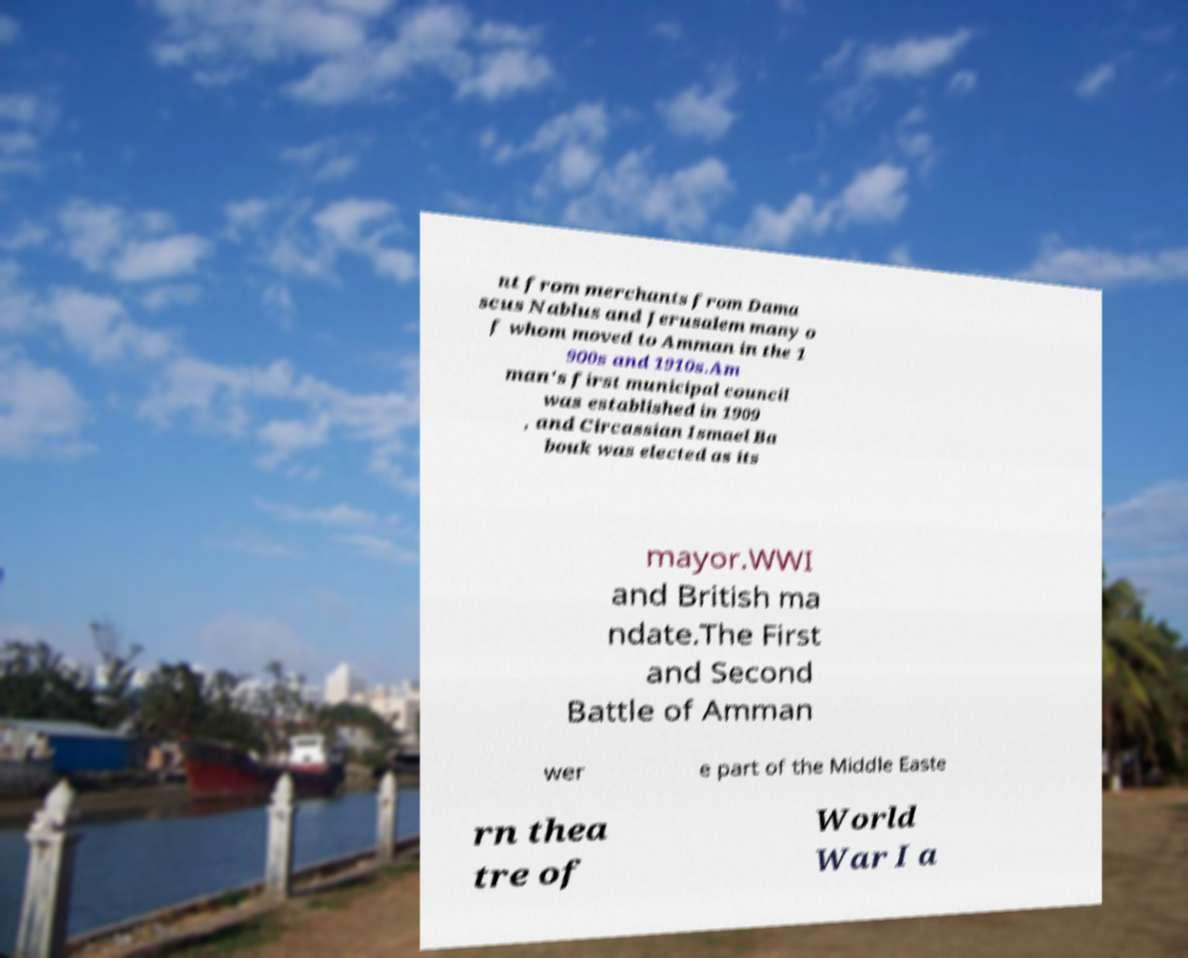Can you accurately transcribe the text from the provided image for me? nt from merchants from Dama scus Nablus and Jerusalem many o f whom moved to Amman in the 1 900s and 1910s.Am man's first municipal council was established in 1909 , and Circassian Ismael Ba bouk was elected as its mayor.WWI and British ma ndate.The First and Second Battle of Amman wer e part of the Middle Easte rn thea tre of World War I a 